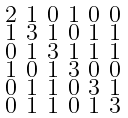<formula> <loc_0><loc_0><loc_500><loc_500>\begin{smallmatrix} 2 & 1 & 0 & 1 & 0 & 0 \\ 1 & 3 & 1 & 0 & 1 & 1 \\ 0 & 1 & 3 & 1 & 1 & 1 \\ 1 & 0 & 1 & 3 & 0 & 0 \\ 0 & 1 & 1 & 0 & 3 & 1 \\ 0 & 1 & 1 & 0 & 1 & 3 \end{smallmatrix}</formula> 